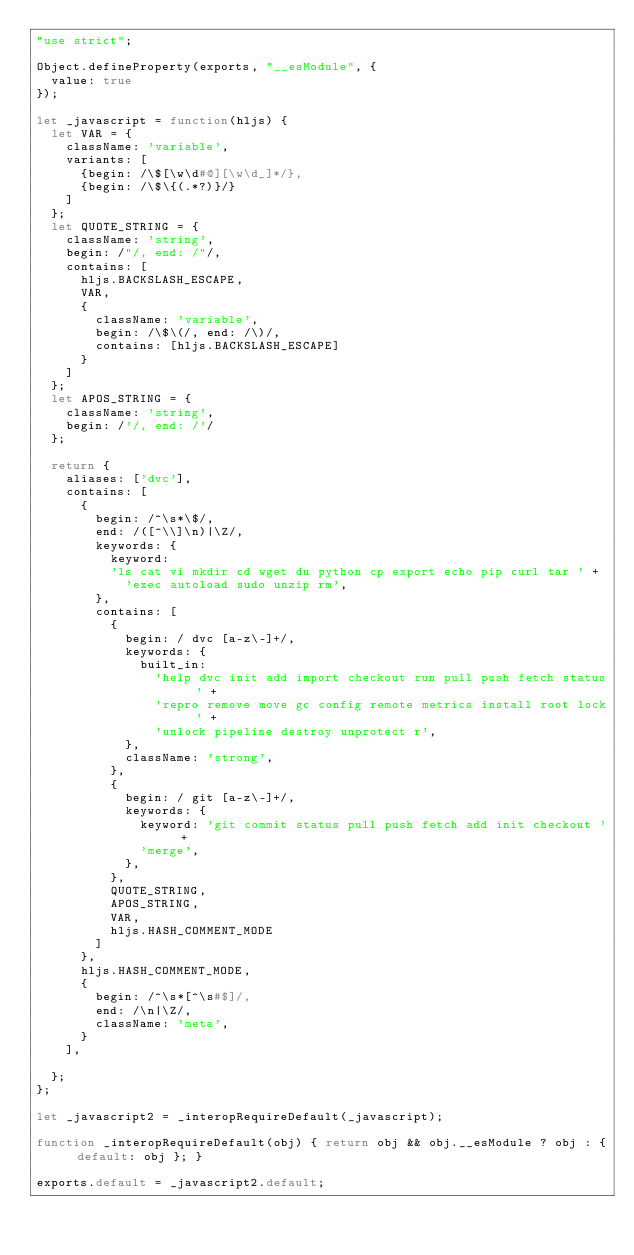Convert code to text. <code><loc_0><loc_0><loc_500><loc_500><_JavaScript_>"use strict";

Object.defineProperty(exports, "__esModule", {
  value: true
});

let _javascript = function(hljs) {
  let VAR = {
    className: 'variable',
    variants: [
      {begin: /\$[\w\d#@][\w\d_]*/},
      {begin: /\$\{(.*?)}/}
    ]
  };
  let QUOTE_STRING = {
    className: 'string',
    begin: /"/, end: /"/,
    contains: [
      hljs.BACKSLASH_ESCAPE,
      VAR,
      {
        className: 'variable',
        begin: /\$\(/, end: /\)/,
        contains: [hljs.BACKSLASH_ESCAPE]
      }
    ]
  };
  let APOS_STRING = {
    className: 'string',
    begin: /'/, end: /'/
  };

  return {
    aliases: ['dvc'],
    contains: [
      {
        begin: /^\s*\$/,
        end: /([^\\]\n)|\Z/,
        keywords: {
          keyword:
          'ls cat vi mkdir cd wget du python cp export echo pip curl tar ' +
            'exec autoload sudo unzip rm',
        },
        contains: [
          {
            begin: / dvc [a-z\-]+/,
            keywords: {
              built_in:
                'help dvc init add import checkout run pull push fetch status ' +
                'repro remove move gc config remote metrics install root lock ' +
                'unlock pipeline destroy unprotect r',
            },
            className: 'strong',
          },
          {
            begin: / git [a-z\-]+/,
            keywords: {
              keyword: 'git commit status pull push fetch add init checkout ' +
              'merge',
            },
          },
          QUOTE_STRING,
          APOS_STRING,
          VAR,
          hljs.HASH_COMMENT_MODE
        ]
      },
      hljs.HASH_COMMENT_MODE,
      {
        begin: /^\s*[^\s#$]/,
        end: /\n|\Z/,
        className: 'meta',
      }
    ],

  };
};

let _javascript2 = _interopRequireDefault(_javascript);

function _interopRequireDefault(obj) { return obj && obj.__esModule ? obj : { default: obj }; }

exports.default = _javascript2.default;
</code> 